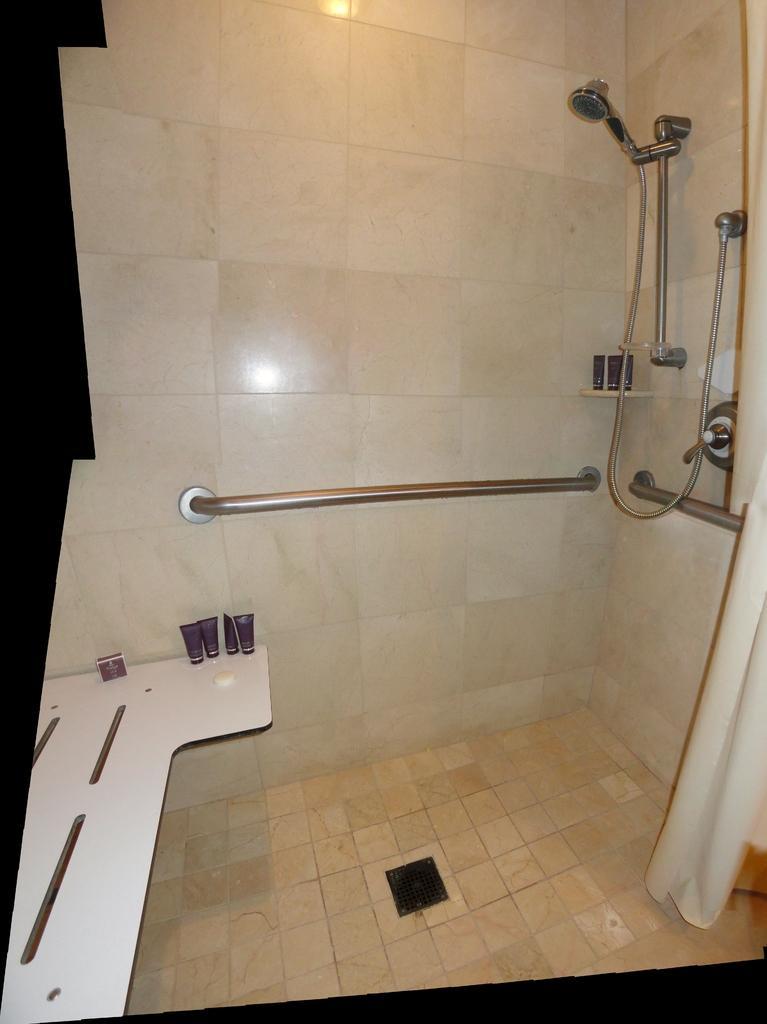In one or two sentences, can you explain what this image depicts? This image is taken in the bathroom. On the right side of the image there is a shower. On the left we can see a counter top and there are toiletries placed on the countertop. In the background there is a wall. 